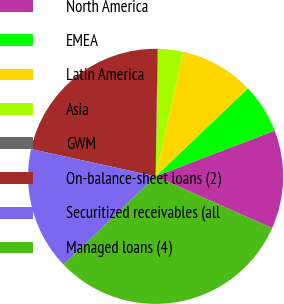<chart> <loc_0><loc_0><loc_500><loc_500><pie_chart><fcel>North America<fcel>EMEA<fcel>Latin America<fcel>Asia<fcel>GWM<fcel>On-balance-sheet loans (2)<fcel>Securitized receivables (all<fcel>Managed loans (4)<nl><fcel>12.5%<fcel>6.28%<fcel>9.39%<fcel>3.18%<fcel>0.07%<fcel>21.8%<fcel>15.61%<fcel>31.16%<nl></chart> 